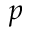<formula> <loc_0><loc_0><loc_500><loc_500>p</formula> 